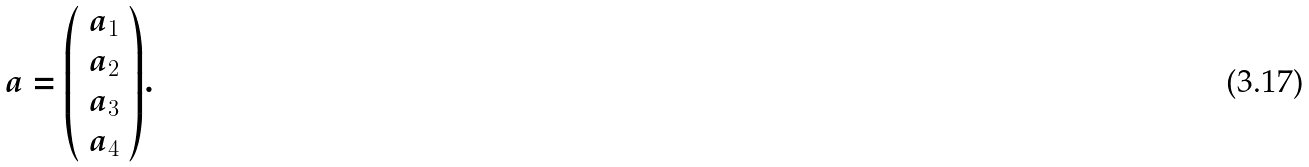<formula> <loc_0><loc_0><loc_500><loc_500>a = { \left ( \begin{array} { l } { a _ { 1 } } \\ { a _ { 2 } } \\ { a _ { 3 } } \\ { a _ { 4 } } \end{array} \right ) } .</formula> 